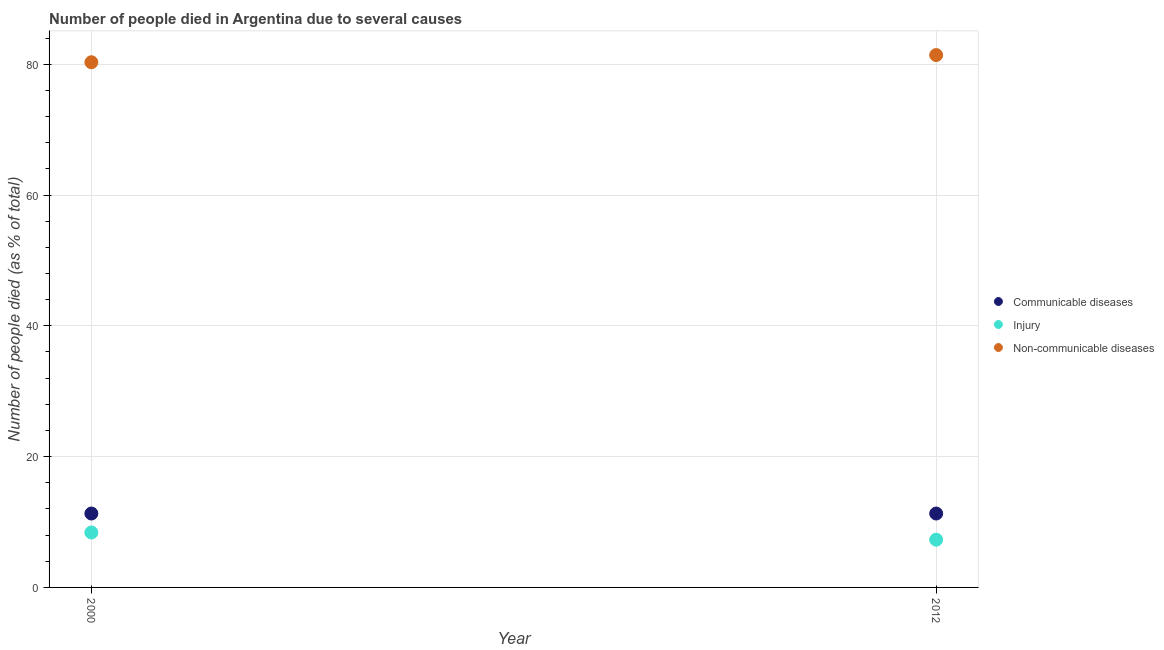How many different coloured dotlines are there?
Ensure brevity in your answer.  3. Is the number of dotlines equal to the number of legend labels?
Provide a short and direct response. Yes. What is the number of people who died of communicable diseases in 2000?
Your answer should be compact. 11.3. Across all years, what is the maximum number of people who died of injury?
Keep it short and to the point. 8.4. Across all years, what is the minimum number of people who dies of non-communicable diseases?
Provide a short and direct response. 80.3. In which year was the number of people who died of injury maximum?
Provide a succinct answer. 2000. What is the total number of people who dies of non-communicable diseases in the graph?
Provide a succinct answer. 161.7. What is the difference between the number of people who died of injury in 2000 and that in 2012?
Your answer should be very brief. 1.1. What is the difference between the number of people who dies of non-communicable diseases in 2012 and the number of people who died of communicable diseases in 2000?
Provide a succinct answer. 70.1. What is the average number of people who dies of non-communicable diseases per year?
Provide a succinct answer. 80.85. In the year 2000, what is the difference between the number of people who died of communicable diseases and number of people who died of injury?
Provide a short and direct response. 2.9. Does the number of people who dies of non-communicable diseases monotonically increase over the years?
Make the answer very short. Yes. Is the number of people who died of communicable diseases strictly greater than the number of people who died of injury over the years?
Your answer should be compact. Yes. Is the number of people who died of injury strictly less than the number of people who dies of non-communicable diseases over the years?
Ensure brevity in your answer.  Yes. How many dotlines are there?
Your answer should be compact. 3. Are the values on the major ticks of Y-axis written in scientific E-notation?
Ensure brevity in your answer.  No. Does the graph contain grids?
Provide a succinct answer. Yes. How are the legend labels stacked?
Make the answer very short. Vertical. What is the title of the graph?
Your answer should be very brief. Number of people died in Argentina due to several causes. What is the label or title of the Y-axis?
Your answer should be compact. Number of people died (as % of total). What is the Number of people died (as % of total) of Injury in 2000?
Keep it short and to the point. 8.4. What is the Number of people died (as % of total) in Non-communicable diseases in 2000?
Make the answer very short. 80.3. What is the Number of people died (as % of total) in Injury in 2012?
Make the answer very short. 7.3. What is the Number of people died (as % of total) in Non-communicable diseases in 2012?
Your answer should be very brief. 81.4. Across all years, what is the maximum Number of people died (as % of total) of Communicable diseases?
Keep it short and to the point. 11.3. Across all years, what is the maximum Number of people died (as % of total) in Non-communicable diseases?
Your response must be concise. 81.4. Across all years, what is the minimum Number of people died (as % of total) of Injury?
Give a very brief answer. 7.3. Across all years, what is the minimum Number of people died (as % of total) of Non-communicable diseases?
Give a very brief answer. 80.3. What is the total Number of people died (as % of total) of Communicable diseases in the graph?
Provide a succinct answer. 22.6. What is the total Number of people died (as % of total) in Injury in the graph?
Offer a terse response. 15.7. What is the total Number of people died (as % of total) in Non-communicable diseases in the graph?
Offer a very short reply. 161.7. What is the difference between the Number of people died (as % of total) in Communicable diseases in 2000 and that in 2012?
Ensure brevity in your answer.  0. What is the difference between the Number of people died (as % of total) of Injury in 2000 and that in 2012?
Provide a succinct answer. 1.1. What is the difference between the Number of people died (as % of total) of Communicable diseases in 2000 and the Number of people died (as % of total) of Non-communicable diseases in 2012?
Provide a short and direct response. -70.1. What is the difference between the Number of people died (as % of total) of Injury in 2000 and the Number of people died (as % of total) of Non-communicable diseases in 2012?
Offer a very short reply. -73. What is the average Number of people died (as % of total) of Communicable diseases per year?
Make the answer very short. 11.3. What is the average Number of people died (as % of total) in Injury per year?
Ensure brevity in your answer.  7.85. What is the average Number of people died (as % of total) of Non-communicable diseases per year?
Provide a succinct answer. 80.85. In the year 2000, what is the difference between the Number of people died (as % of total) in Communicable diseases and Number of people died (as % of total) in Non-communicable diseases?
Provide a short and direct response. -69. In the year 2000, what is the difference between the Number of people died (as % of total) of Injury and Number of people died (as % of total) of Non-communicable diseases?
Provide a succinct answer. -71.9. In the year 2012, what is the difference between the Number of people died (as % of total) of Communicable diseases and Number of people died (as % of total) of Non-communicable diseases?
Your answer should be compact. -70.1. In the year 2012, what is the difference between the Number of people died (as % of total) of Injury and Number of people died (as % of total) of Non-communicable diseases?
Offer a very short reply. -74.1. What is the ratio of the Number of people died (as % of total) of Injury in 2000 to that in 2012?
Your response must be concise. 1.15. What is the ratio of the Number of people died (as % of total) of Non-communicable diseases in 2000 to that in 2012?
Your answer should be compact. 0.99. What is the difference between the highest and the second highest Number of people died (as % of total) in Injury?
Make the answer very short. 1.1. What is the difference between the highest and the second highest Number of people died (as % of total) of Non-communicable diseases?
Offer a terse response. 1.1. What is the difference between the highest and the lowest Number of people died (as % of total) of Communicable diseases?
Your response must be concise. 0. What is the difference between the highest and the lowest Number of people died (as % of total) in Injury?
Provide a succinct answer. 1.1. 